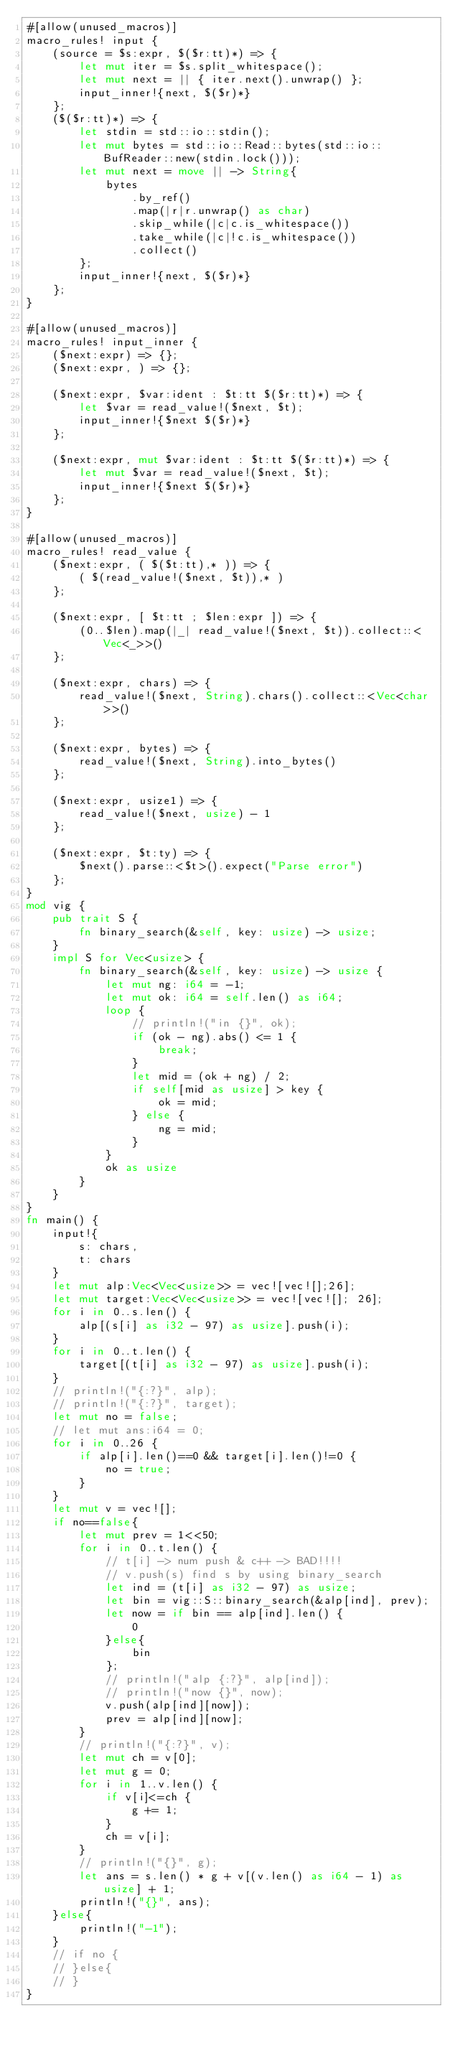Convert code to text. <code><loc_0><loc_0><loc_500><loc_500><_Rust_>#[allow(unused_macros)]
macro_rules! input {
    (source = $s:expr, $($r:tt)*) => {
        let mut iter = $s.split_whitespace();
        let mut next = || { iter.next().unwrap() };
        input_inner!{next, $($r)*}
    };
    ($($r:tt)*) => {
        let stdin = std::io::stdin();
        let mut bytes = std::io::Read::bytes(std::io::BufReader::new(stdin.lock()));
        let mut next = move || -> String{
            bytes
                .by_ref()
                .map(|r|r.unwrap() as char)
                .skip_while(|c|c.is_whitespace())
                .take_while(|c|!c.is_whitespace())
                .collect()
        };
        input_inner!{next, $($r)*}
    };
}

#[allow(unused_macros)]
macro_rules! input_inner {
    ($next:expr) => {};
    ($next:expr, ) => {};

    ($next:expr, $var:ident : $t:tt $($r:tt)*) => {
        let $var = read_value!($next, $t);
        input_inner!{$next $($r)*}
    };

    ($next:expr, mut $var:ident : $t:tt $($r:tt)*) => {
        let mut $var = read_value!($next, $t);
        input_inner!{$next $($r)*}
    };
}

#[allow(unused_macros)]
macro_rules! read_value {
    ($next:expr, ( $($t:tt),* )) => {
        ( $(read_value!($next, $t)),* )
    };

    ($next:expr, [ $t:tt ; $len:expr ]) => {
        (0..$len).map(|_| read_value!($next, $t)).collect::<Vec<_>>()
    };

    ($next:expr, chars) => {
        read_value!($next, String).chars().collect::<Vec<char>>()
    };

    ($next:expr, bytes) => {
        read_value!($next, String).into_bytes()
    };

    ($next:expr, usize1) => {
        read_value!($next, usize) - 1
    };

    ($next:expr, $t:ty) => {
        $next().parse::<$t>().expect("Parse error")
    };
}
mod vig {
    pub trait S {
        fn binary_search(&self, key: usize) -> usize;
    }
    impl S for Vec<usize> {
        fn binary_search(&self, key: usize) -> usize {
            let mut ng: i64 = -1;
            let mut ok: i64 = self.len() as i64;
            loop {
                // println!("in {}", ok);
                if (ok - ng).abs() <= 1 {
                    break;
                }
                let mid = (ok + ng) / 2;
                if self[mid as usize] > key {
                    ok = mid;
                } else {
                    ng = mid;
                }
            }
            ok as usize
        }
    }
}
fn main() {
    input!{
        s: chars,
        t: chars
    }
    let mut alp:Vec<Vec<usize>> = vec![vec![];26];
    let mut target:Vec<Vec<usize>> = vec![vec![]; 26];
    for i in 0..s.len() {
        alp[(s[i] as i32 - 97) as usize].push(i);
    }
    for i in 0..t.len() {
        target[(t[i] as i32 - 97) as usize].push(i);
    }
    // println!("{:?}", alp);
    // println!("{:?}", target);
    let mut no = false;
    // let mut ans:i64 = 0;
    for i in 0..26 {
        if alp[i].len()==0 && target[i].len()!=0 {
            no = true;
        }
    }
    let mut v = vec![];
    if no==false{
        let mut prev = 1<<50;
        for i in 0..t.len() {
            // t[i] -> num push & c++ -> BAD!!!!
            // v.push(s) find s by using binary_search
            let ind = (t[i] as i32 - 97) as usize;
            let bin = vig::S::binary_search(&alp[ind], prev);
            let now = if bin == alp[ind].len() {
                0
            }else{
                bin
            };
            // println!("alp {:?}", alp[ind]);
            // println!("now {}", now);
            v.push(alp[ind][now]);
            prev = alp[ind][now];
        }
        // println!("{:?}", v);
        let mut ch = v[0];
        let mut g = 0;
        for i in 1..v.len() {
            if v[i]<=ch {
                g += 1;
            }
            ch = v[i];
        }
        // println!("{}", g);
        let ans = s.len() * g + v[(v.len() as i64 - 1) as usize] + 1;
        println!("{}", ans);
    }else{
        println!("-1");
    }
    // if no {
    // }else{
    // }
}</code> 